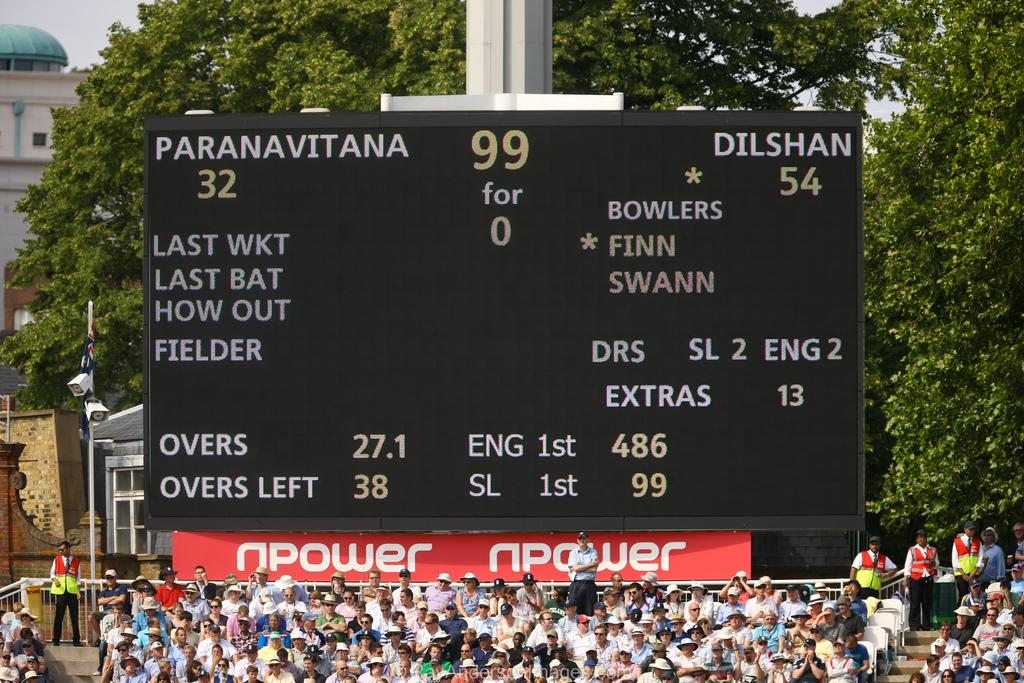<image>
Offer a succinct explanation of the picture presented. A crowded stadium on a sunny day with a scoreboard showing one team is beating the other 54 to 32. 